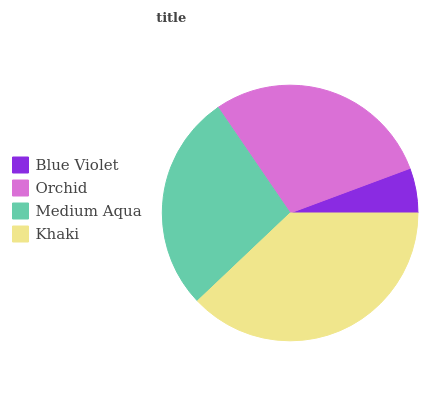Is Blue Violet the minimum?
Answer yes or no. Yes. Is Khaki the maximum?
Answer yes or no. Yes. Is Orchid the minimum?
Answer yes or no. No. Is Orchid the maximum?
Answer yes or no. No. Is Orchid greater than Blue Violet?
Answer yes or no. Yes. Is Blue Violet less than Orchid?
Answer yes or no. Yes. Is Blue Violet greater than Orchid?
Answer yes or no. No. Is Orchid less than Blue Violet?
Answer yes or no. No. Is Orchid the high median?
Answer yes or no. Yes. Is Medium Aqua the low median?
Answer yes or no. Yes. Is Blue Violet the high median?
Answer yes or no. No. Is Khaki the low median?
Answer yes or no. No. 